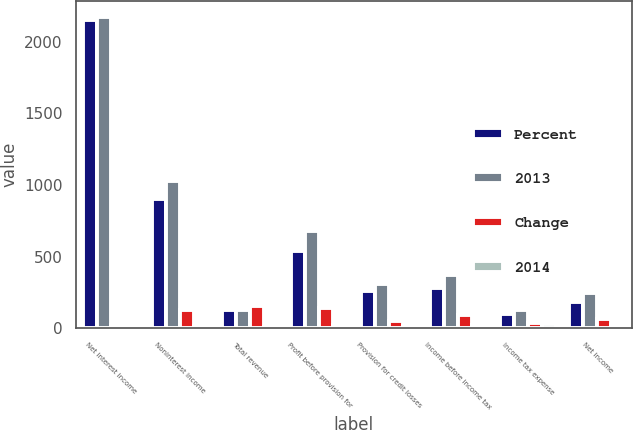Convert chart. <chart><loc_0><loc_0><loc_500><loc_500><stacked_bar_chart><ecel><fcel>Net interest income<fcel>Noninterest income<fcel>Total revenue<fcel>Profit before provision for<fcel>Provision for credit losses<fcel>Income before income tax<fcel>Income tax expense<fcel>Net income<nl><fcel>Percent<fcel>2151<fcel>899<fcel>127.5<fcel>537<fcel>259<fcel>278<fcel>96<fcel>182<nl><fcel>2013<fcel>2176<fcel>1025<fcel>127.5<fcel>679<fcel>308<fcel>371<fcel>129<fcel>242<nl><fcel>Change<fcel>25<fcel>126<fcel>151<fcel>142<fcel>49<fcel>93<fcel>33<fcel>60<nl><fcel>2014<fcel>1<fcel>12<fcel>5<fcel>21<fcel>16<fcel>25<fcel>26<fcel>25<nl></chart> 